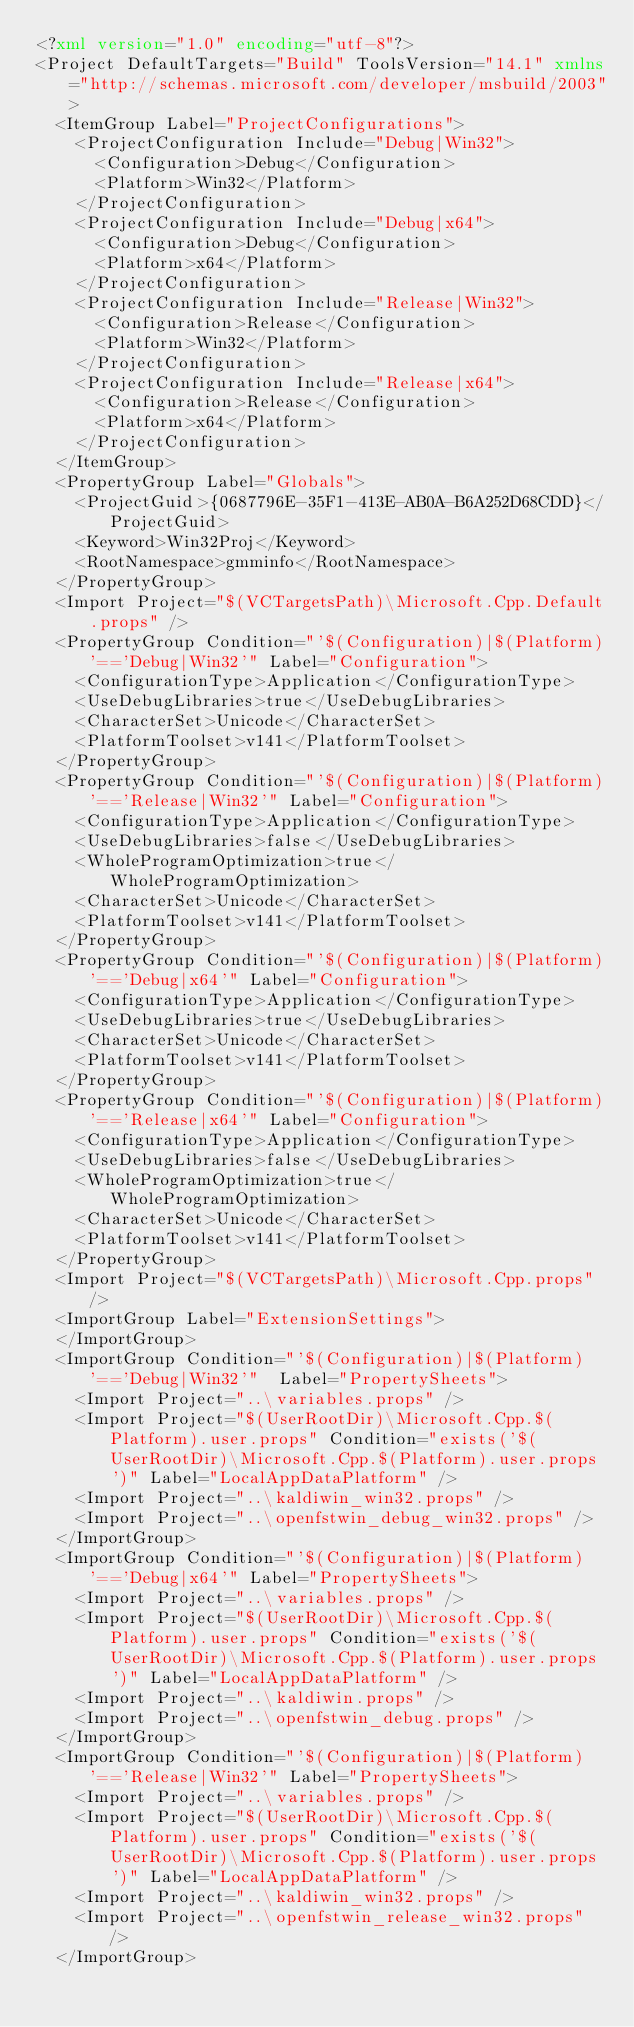<code> <loc_0><loc_0><loc_500><loc_500><_XML_><?xml version="1.0" encoding="utf-8"?>
<Project DefaultTargets="Build" ToolsVersion="14.1" xmlns="http://schemas.microsoft.com/developer/msbuild/2003">
  <ItemGroup Label="ProjectConfigurations">
    <ProjectConfiguration Include="Debug|Win32">
      <Configuration>Debug</Configuration>
      <Platform>Win32</Platform>
    </ProjectConfiguration>
    <ProjectConfiguration Include="Debug|x64">
      <Configuration>Debug</Configuration>
      <Platform>x64</Platform>
    </ProjectConfiguration>
    <ProjectConfiguration Include="Release|Win32">
      <Configuration>Release</Configuration>
      <Platform>Win32</Platform>
    </ProjectConfiguration>
    <ProjectConfiguration Include="Release|x64">
      <Configuration>Release</Configuration>
      <Platform>x64</Platform>
    </ProjectConfiguration>
  </ItemGroup>
  <PropertyGroup Label="Globals">
    <ProjectGuid>{0687796E-35F1-413E-AB0A-B6A252D68CDD}</ProjectGuid>
    <Keyword>Win32Proj</Keyword>
    <RootNamespace>gmminfo</RootNamespace>
  </PropertyGroup>
  <Import Project="$(VCTargetsPath)\Microsoft.Cpp.Default.props" />
  <PropertyGroup Condition="'$(Configuration)|$(Platform)'=='Debug|Win32'" Label="Configuration">
    <ConfigurationType>Application</ConfigurationType>
    <UseDebugLibraries>true</UseDebugLibraries>
    <CharacterSet>Unicode</CharacterSet>
    <PlatformToolset>v141</PlatformToolset>
  </PropertyGroup>
  <PropertyGroup Condition="'$(Configuration)|$(Platform)'=='Release|Win32'" Label="Configuration">
    <ConfigurationType>Application</ConfigurationType>
    <UseDebugLibraries>false</UseDebugLibraries>
    <WholeProgramOptimization>true</WholeProgramOptimization>
    <CharacterSet>Unicode</CharacterSet>
    <PlatformToolset>v141</PlatformToolset>
  </PropertyGroup>
  <PropertyGroup Condition="'$(Configuration)|$(Platform)'=='Debug|x64'" Label="Configuration">
    <ConfigurationType>Application</ConfigurationType>
    <UseDebugLibraries>true</UseDebugLibraries>
    <CharacterSet>Unicode</CharacterSet>
    <PlatformToolset>v141</PlatformToolset>
  </PropertyGroup>
  <PropertyGroup Condition="'$(Configuration)|$(Platform)'=='Release|x64'" Label="Configuration">
    <ConfigurationType>Application</ConfigurationType>
    <UseDebugLibraries>false</UseDebugLibraries>
    <WholeProgramOptimization>true</WholeProgramOptimization>
    <CharacterSet>Unicode</CharacterSet>
    <PlatformToolset>v141</PlatformToolset>
  </PropertyGroup>
  <Import Project="$(VCTargetsPath)\Microsoft.Cpp.props" />
  <ImportGroup Label="ExtensionSettings">
  </ImportGroup>
  <ImportGroup Condition="'$(Configuration)|$(Platform)'=='Debug|Win32'"  Label="PropertySheets">
    <Import Project="..\variables.props" />
    <Import Project="$(UserRootDir)\Microsoft.Cpp.$(Platform).user.props" Condition="exists('$(UserRootDir)\Microsoft.Cpp.$(Platform).user.props')" Label="LocalAppDataPlatform" />
    <Import Project="..\kaldiwin_win32.props" />
    <Import Project="..\openfstwin_debug_win32.props" />
  </ImportGroup>
  <ImportGroup Condition="'$(Configuration)|$(Platform)'=='Debug|x64'" Label="PropertySheets">
    <Import Project="..\variables.props" />
    <Import Project="$(UserRootDir)\Microsoft.Cpp.$(Platform).user.props" Condition="exists('$(UserRootDir)\Microsoft.Cpp.$(Platform).user.props')" Label="LocalAppDataPlatform" />
    <Import Project="..\kaldiwin.props" />
    <Import Project="..\openfstwin_debug.props" />
  </ImportGroup>
  <ImportGroup Condition="'$(Configuration)|$(Platform)'=='Release|Win32'" Label="PropertySheets">
    <Import Project="..\variables.props" />
    <Import Project="$(UserRootDir)\Microsoft.Cpp.$(Platform).user.props" Condition="exists('$(UserRootDir)\Microsoft.Cpp.$(Platform).user.props')" Label="LocalAppDataPlatform" />
    <Import Project="..\kaldiwin_win32.props" />
    <Import Project="..\openfstwin_release_win32.props" />
  </ImportGroup></code> 